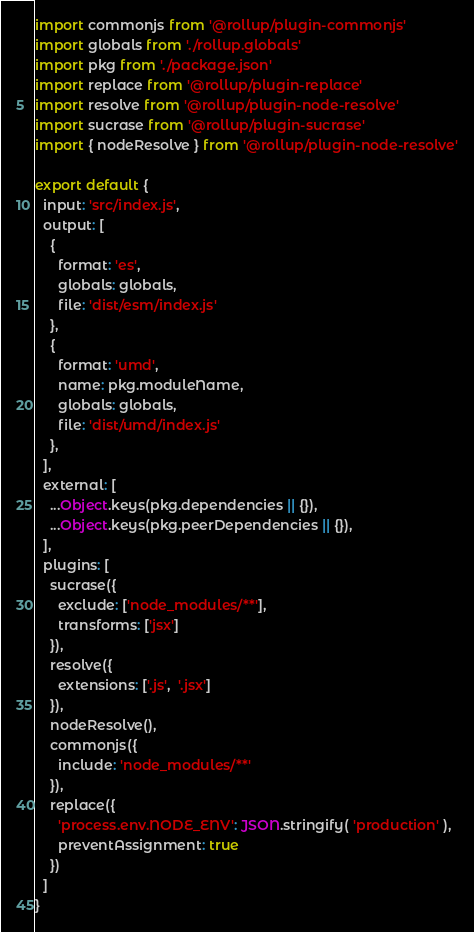Convert code to text. <code><loc_0><loc_0><loc_500><loc_500><_JavaScript_>import commonjs from '@rollup/plugin-commonjs'
import globals from './rollup.globals'
import pkg from './package.json'
import replace from '@rollup/plugin-replace'
import resolve from '@rollup/plugin-node-resolve'
import sucrase from '@rollup/plugin-sucrase'
import { nodeResolve } from '@rollup/plugin-node-resolve'

export default {
  input: 'src/index.js',
  output: [
    {
      format: 'es',
      globals: globals,
      file: 'dist/esm/index.js'
    },
    {
      format: 'umd',
      name: pkg.moduleName,
      globals: globals,
      file: 'dist/umd/index.js'
    },
  ],
  external: [
    ...Object.keys(pkg.dependencies || {}),
    ...Object.keys(pkg.peerDependencies || {}),
  ],
  plugins: [
    sucrase({
      exclude: ['node_modules/**'],
      transforms: ['jsx']
    }),
    resolve({
      extensions: ['.js',  '.jsx']
    }),
    nodeResolve(),
    commonjs({
      include: 'node_modules/**'
    }),
    replace({
      'process.env.NODE_ENV': JSON.stringify( 'production' ),
      preventAssignment: true
    })
  ]
}
</code> 